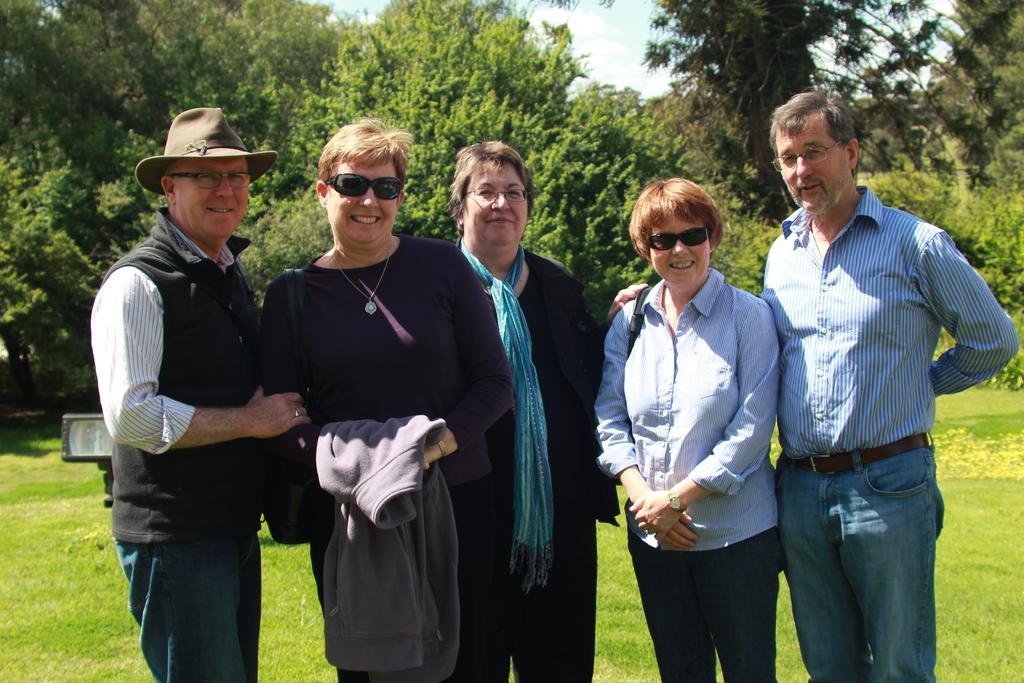Describe this image in one or two sentences. In this image we can see few people standing on the ground, in the background there are few trees, sky and an object looks like a light. 